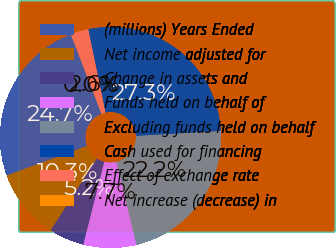<chart> <loc_0><loc_0><loc_500><loc_500><pie_chart><fcel>(millions) Years Ended<fcel>Net income adjusted for<fcel>Change in assets and<fcel>Funds held on behalf of<fcel>Excluding funds held on behalf<fcel>Cash used for financing<fcel>Effect of exchange rate<fcel>Net increase (decrease) in<nl><fcel>24.74%<fcel>10.29%<fcel>5.16%<fcel>7.72%<fcel>22.17%<fcel>27.31%<fcel>2.59%<fcel>0.02%<nl></chart> 